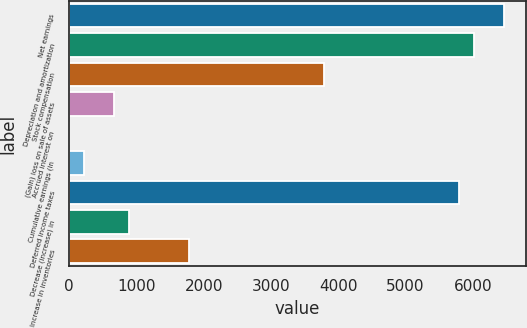Convert chart to OTSL. <chart><loc_0><loc_0><loc_500><loc_500><bar_chart><fcel>Net earnings<fcel>Depreciation and amortization<fcel>Stock compensation<fcel>(Gain) loss on sale of assets<fcel>Accrued interest on<fcel>Cumulative earnings (in<fcel>Deferred income taxes<fcel>Decrease (increase) in<fcel>Increase in inventories<nl><fcel>6462.66<fcel>6016.98<fcel>3788.58<fcel>668.82<fcel>0.3<fcel>223.14<fcel>5794.14<fcel>891.66<fcel>1783.02<nl></chart> 